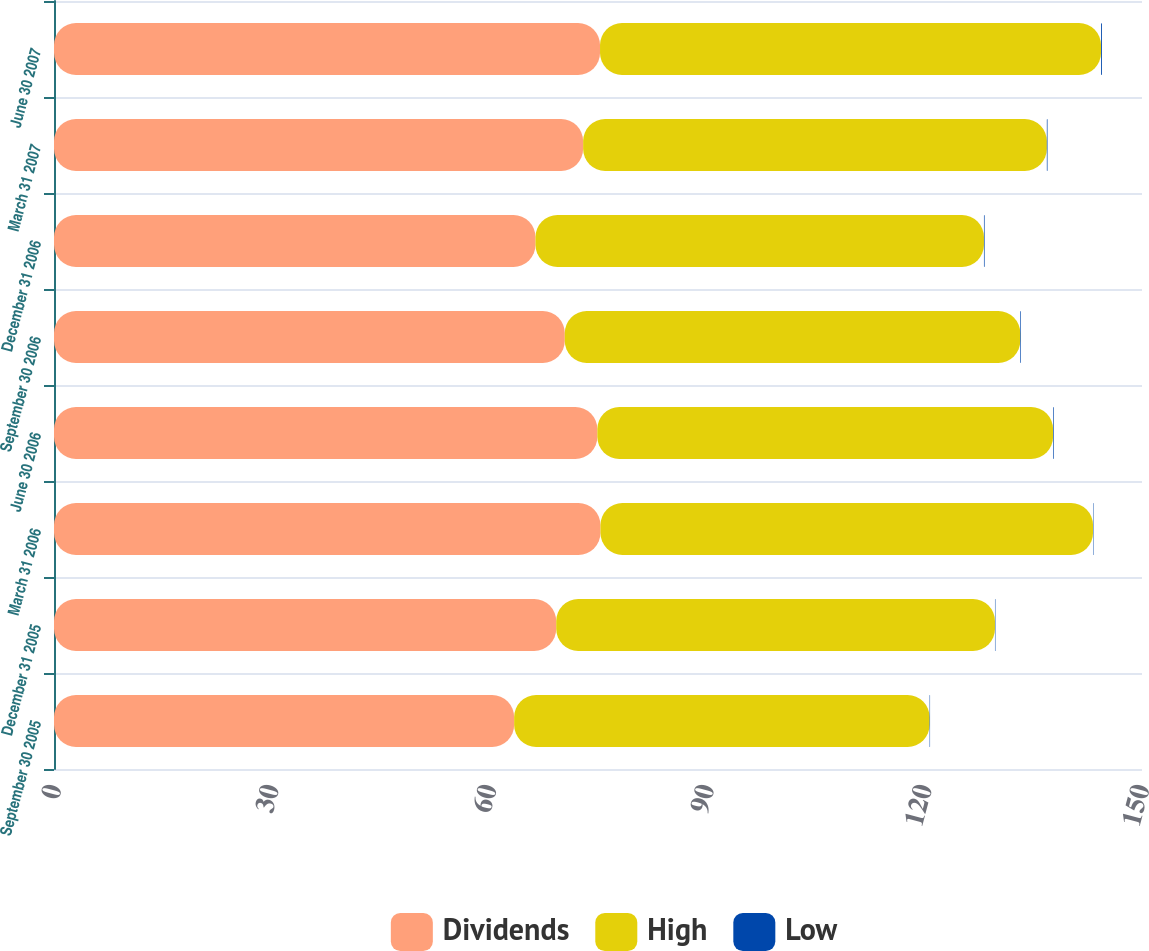<chart> <loc_0><loc_0><loc_500><loc_500><stacked_bar_chart><ecel><fcel>September 30 2005<fcel>December 31 2005<fcel>March 31 2006<fcel>June 30 2006<fcel>September 30 2006<fcel>December 31 2006<fcel>March 31 2007<fcel>June 30 2007<nl><fcel>Dividends<fcel>63.44<fcel>69.24<fcel>75.34<fcel>74.91<fcel>70.42<fcel>66.38<fcel>72.95<fcel>75.28<nl><fcel>High<fcel>57.28<fcel>60.49<fcel>67.91<fcel>62.83<fcel>62.8<fcel>61.83<fcel>63.93<fcel>69.07<nl><fcel>Low<fcel>0.06<fcel>0.06<fcel>0.06<fcel>0.09<fcel>0.09<fcel>0.09<fcel>0.09<fcel>0.12<nl></chart> 